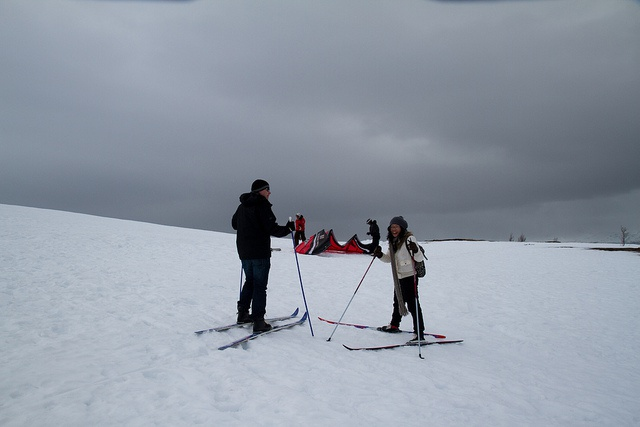Describe the objects in this image and their specific colors. I can see people in darkgray, black, and gray tones, people in darkgray, black, gray, and maroon tones, skis in darkgray, black, and lightblue tones, people in darkgray, black, maroon, and gray tones, and people in darkgray, black, and gray tones in this image. 